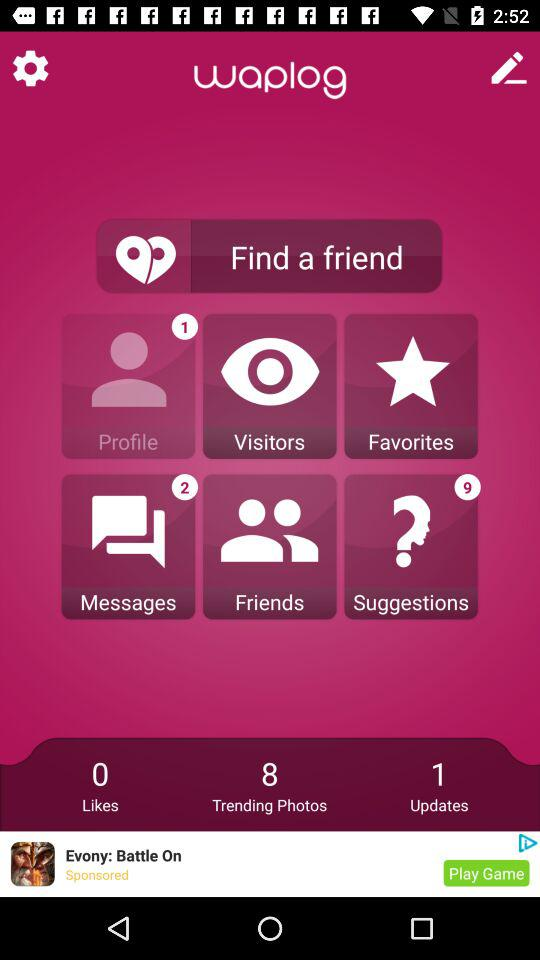Who is this application powered by?
When the provided information is insufficient, respond with <no answer>. <no answer> 